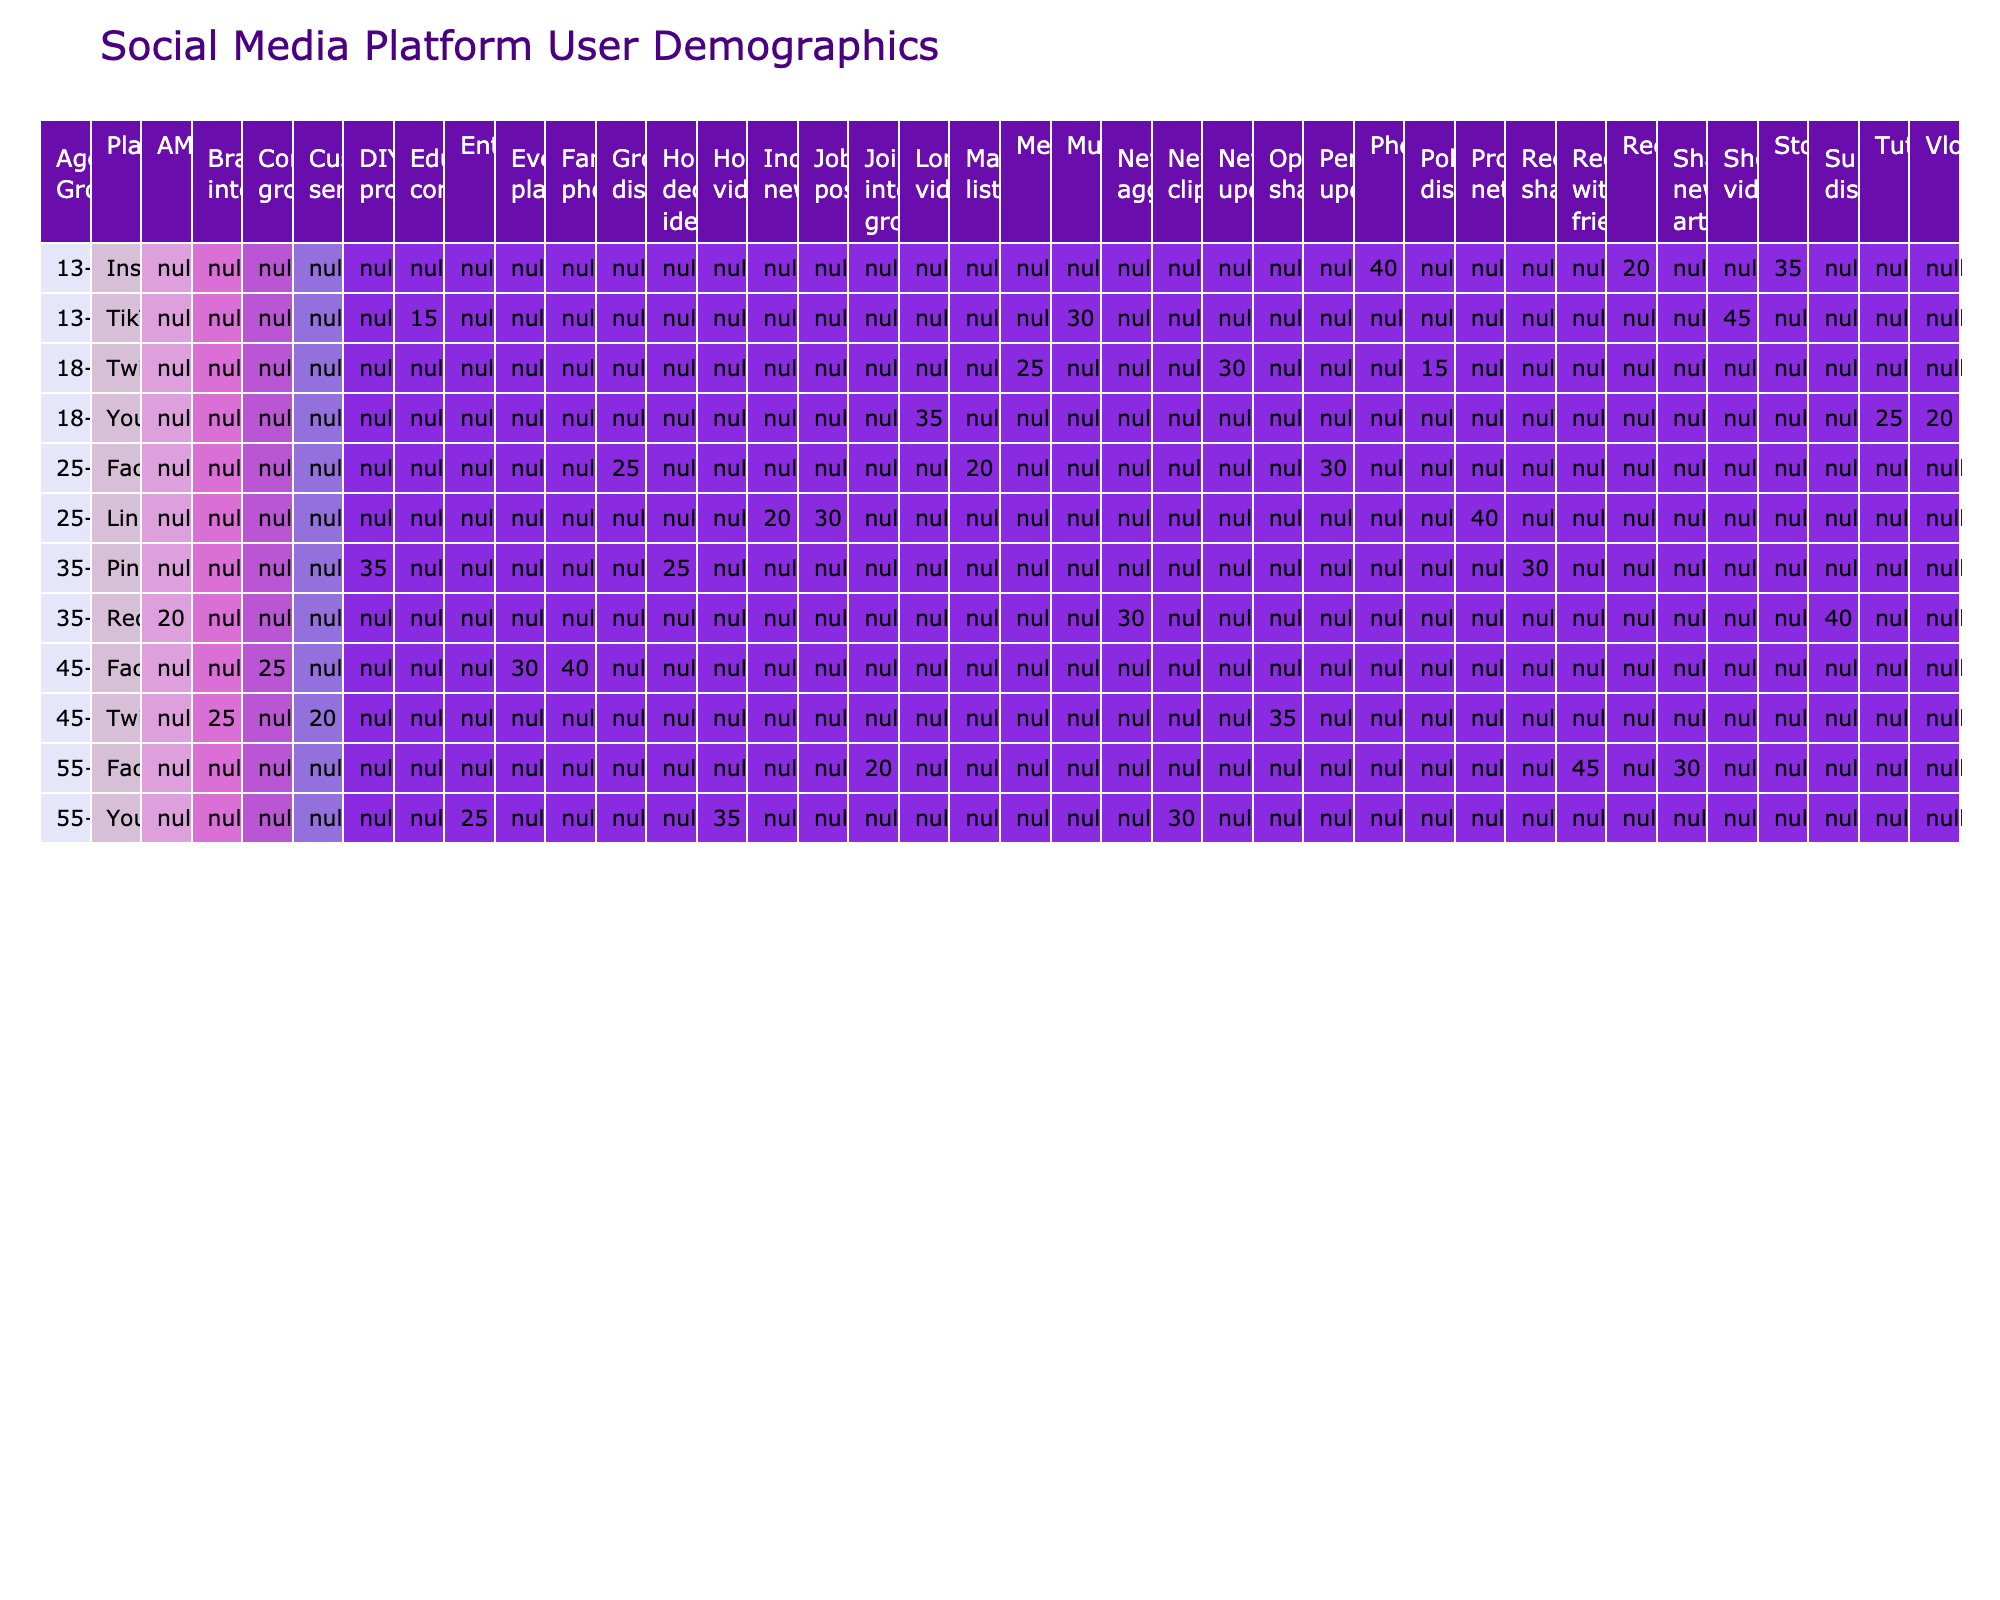What percentage of TikTok users aged 13-17 engage with music-related content? The table indicates that 30% of TikTok users in the 13-17 age group engage with music-related content, as shown in the relevant row for TikTok.
Answer: 30% Which content type has the highest percentage usage for Instagram among 13-17 year olds? Looking at the percentage values for Instagram in the 13-17 age group, photos have the highest percentage at 40%.
Answer: 40% Does the majority of Facebook users aged 55 and older share news articles? The table shows that only 30% of Facebook users aged 55+ share news articles, which is less than half, indicating that the majority do not.
Answer: No What is the total percentage of educational and music-related content consumed by TikTok users aged 13-17? Adding the percentages of educational content (15%) and music-related content (30%) for TikTok users aged 13-17 gives us 15 + 30 = 45%.
Answer: 45% Which social media platform has the highest percentage of content focused on professional networking in the 25-34 age group? The table indicates that LinkedIn has the highest percentage (40%) for professional networking in the 25-34 age group, compared to other platforms.
Answer: LinkedIn What is the difference in percentage between the most popular content type for Facebook users aged 45-54 and the least popular content type for the same age group? For Facebook users aged 45-54, family photos (40%) are the most popular, while customer service (20%) is the least popular. The difference is 40 - 20 = 20%.
Answer: 20% What percentage of YouTube users aged 18-24 prefer long-form videos over tutorials? The table shows that 35% prefer long-form videos, while 25% prefer tutorials. The difference is 35 - 25 = 10%.
Answer: 10% Which content type accounts for the greatest share of usage among Facebook users aged 55 and older? The greatest share of usage among Facebook users aged 55 and older is for reconnecting with friends at 45%, as evident from the data in the table.
Answer: 45% What percentage of Instagram users aged 13-17 engage with stories and reels combined? According to the table, stories account for 35% and reels account for 20% of content for Instagram users aged 13-17. Combined, this totals 35 + 20 = 55%.
Answer: 55% Is the percentage of Twitter users aged 18-24 who engage in political discussions greater than those consuming memes? The table shows that 15% engage in political discussions and 25% engage with memes. Since 15% is less than 25%, the statement is false.
Answer: No What is the percentage of DIY projects among Pinterest users aged 35-44 compared to recipe sharing? The table indicates 35% for DIY projects and 30% for recipe sharing. Comparatively, DIY projects have a greater share at 5% more than recipe sharing.
Answer: 5% more 